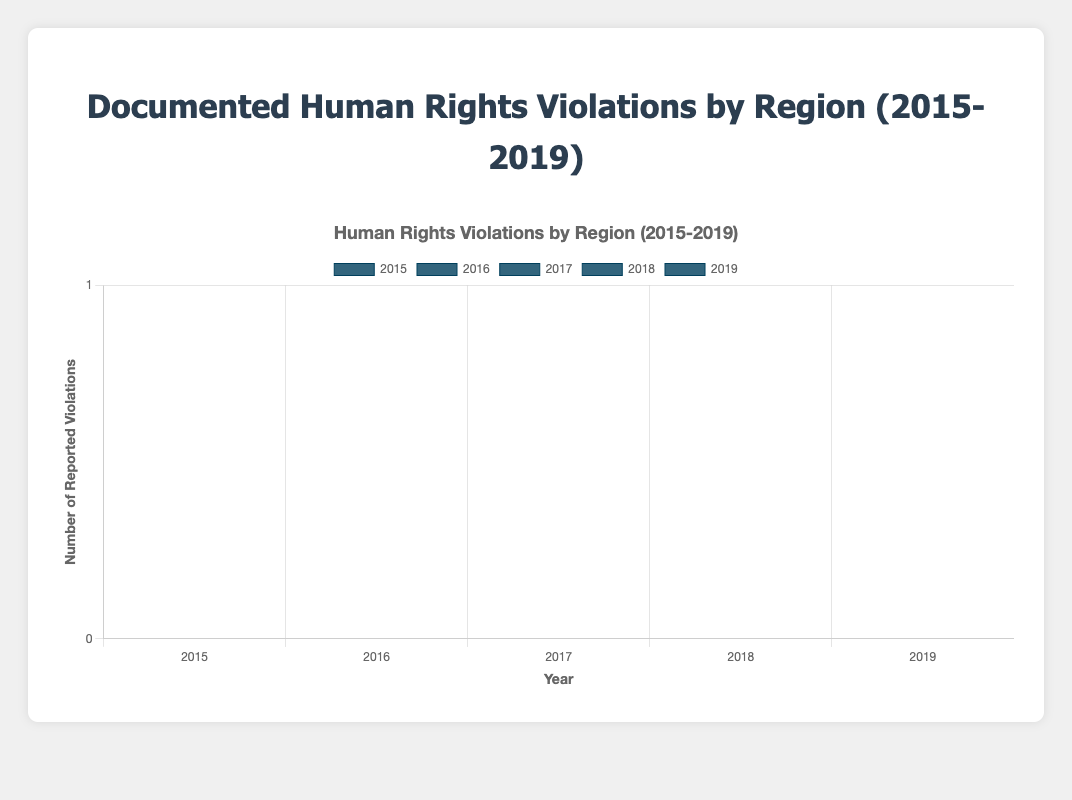What was the total number of reported human rights violations in Asia over the 5-year period? Sum the reported violations for Asia from 2015 to 2019: 1200 + 1300 + 1150 + 1250 + 1100 = 6000
Answer: 6000 Which year had the highest number of documented human rights violations for South America? Compare the reported violations for South America across the years: 2015 (850), 2016 (900), 2017 (870), 2018 (890), 2019 (850). The year 2016 has the highest number with 900 violations.
Answer: 2016 Which region had the highest number of human rights violations in 2018? Compare the 2018 data for all regions: Africa (740), Asia (1250), Europe (330), North America (490), South America (890), Oceania (65). Asia had the highest with 1250 violations.
Answer: Asia What is the average number of reported violations per year in Europe? Sum the reported violations in Europe from 2015 to 2019 and then divide by the number of years: (300 + 320 + 310 + 330 + 290) / 5 = 310
Answer: 310 Compare the number of reported violations in North America and Oceania in 2017. Which region had fewer violations and by how much? Compare the data for 2017: North America (470) vs. Oceania (55). North America had more violations. Calculate the difference: 470 - 55 = 415. Oceania had fewer violations by 415.
Answer: Oceania, 415 What was the decrease in reported violations for Asia from 2016 to 2019? Subtract the 2019 reported violations from the 2016 reported violations for Asia: 1300 - 1100 = 200
Answer: 200 Which region saw the smallest variation in reported violations from 2015 to 2019? Calculate the range (difference between max and min values) for each region:
Africa: 820 - 680 = 140
Asia: 1300 - 1100 = 200
Europe: 330 - 290 = 40
North America: 490 - 450 = 40
South America: 900 - 850 = 50
Oceania: 65 - 50 = 15
Oceania had the smallest variation with a range of 15.
Answer: Oceania What was the total number of reported violations across all regions in 2015? Sum the reported violations across all regions for 2015: 750 (Africa) + 1200 (Asia) + 300 (Europe) + 450 (North America) + 850 (South America) + 50 (Oceania) = 3600
Answer: 3600 